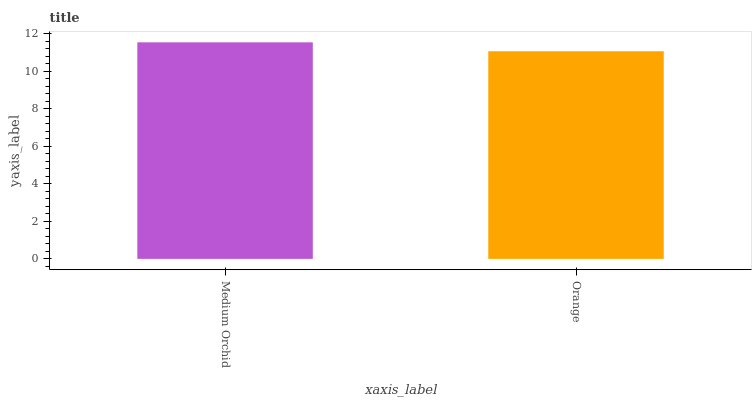Is Orange the minimum?
Answer yes or no. Yes. Is Medium Orchid the maximum?
Answer yes or no. Yes. Is Orange the maximum?
Answer yes or no. No. Is Medium Orchid greater than Orange?
Answer yes or no. Yes. Is Orange less than Medium Orchid?
Answer yes or no. Yes. Is Orange greater than Medium Orchid?
Answer yes or no. No. Is Medium Orchid less than Orange?
Answer yes or no. No. Is Medium Orchid the high median?
Answer yes or no. Yes. Is Orange the low median?
Answer yes or no. Yes. Is Orange the high median?
Answer yes or no. No. Is Medium Orchid the low median?
Answer yes or no. No. 